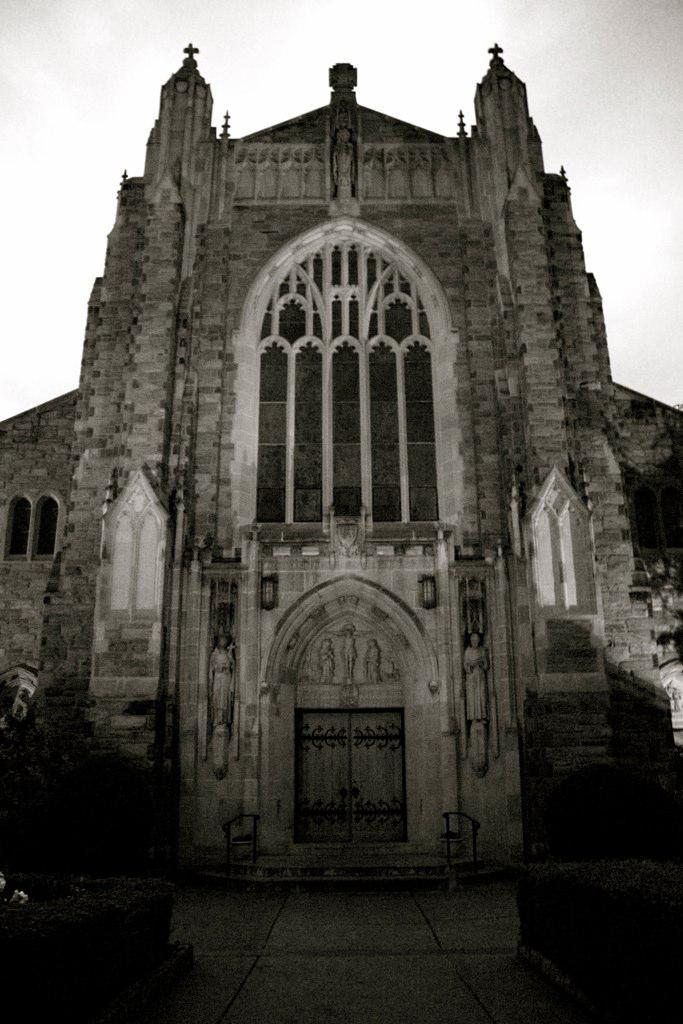What is the main subject in the foreground of the image? There is a building in the foreground of the image. What can be seen at the top of the image? The sky is visible at the top of the image. What is visible at the bottom of the image? There is a floor visible at the bottom of the image. Can you tell me how many people are smiling in the image? There are no people present in the image, so it is not possible to determine how many people might be smiling. 